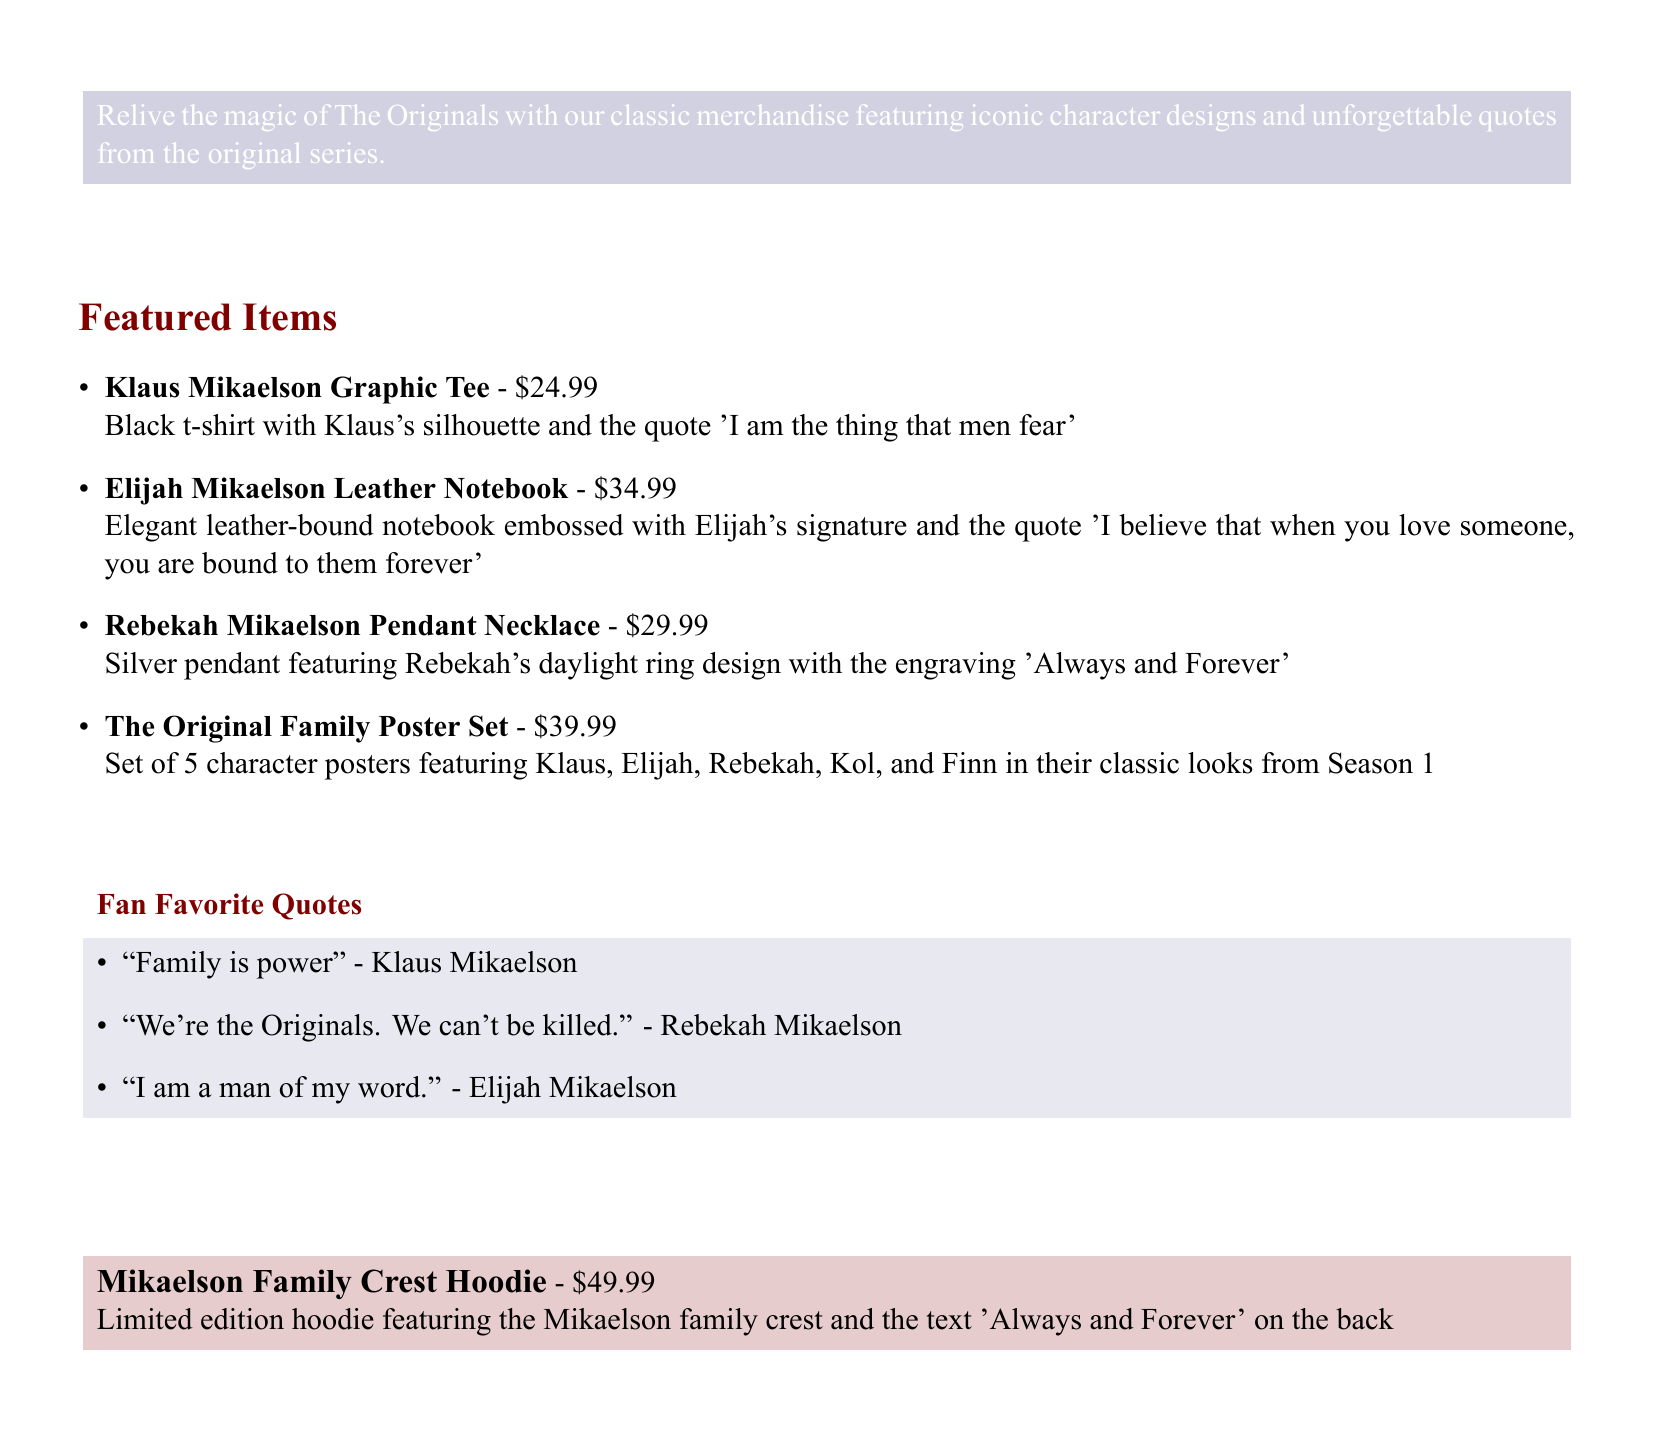What is the price of the Klaus Mikaelson Graphic Tee? The price of the Klaus Mikaelson Graphic Tee is mentioned in the catalog as $24.99.
Answer: $24.99 What quote is featured on the Elijah Mikaelson Leather Notebook? The quote featured on the Elijah Mikaelson Leather Notebook is listed as 'I believe that when you love someone, you are bound to them forever'.
Answer: I believe that when you love someone, you are bound to them forever How many character posters are included in The Original Family Poster Set? The number of character posters in The Original Family Poster Set is stated as 5.
Answer: 5 What is engraved on the Rebekah Mikaelson Pendant Necklace? The engraving on the Rebekah Mikaelson Pendant Necklace is 'Always and Forever'.
Answer: Always and Forever What is the title of the promotional section highlighting quotes? The promotional section highlighting quotes is titled 'Fan Favorite Quotes'.
Answer: Fan Favorite Quotes What is the total price for the Mikaelson Family Crest Hoodie? The total price for the Mikaelson Family Crest Hoodie is indicated as $49.99.
Answer: $49.99 